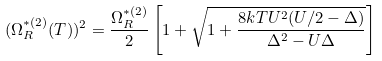<formula> <loc_0><loc_0><loc_500><loc_500>( \Omega _ { R } ^ { * ( 2 ) } ( T ) ) ^ { 2 } = \frac { \Omega _ { R } ^ { * ( 2 ) } } { 2 } \left [ 1 + \sqrt { 1 + \frac { 8 k T U ^ { 2 } ( U / 2 - \Delta ) } { \Delta ^ { 2 } - U \Delta } } \right ]</formula> 